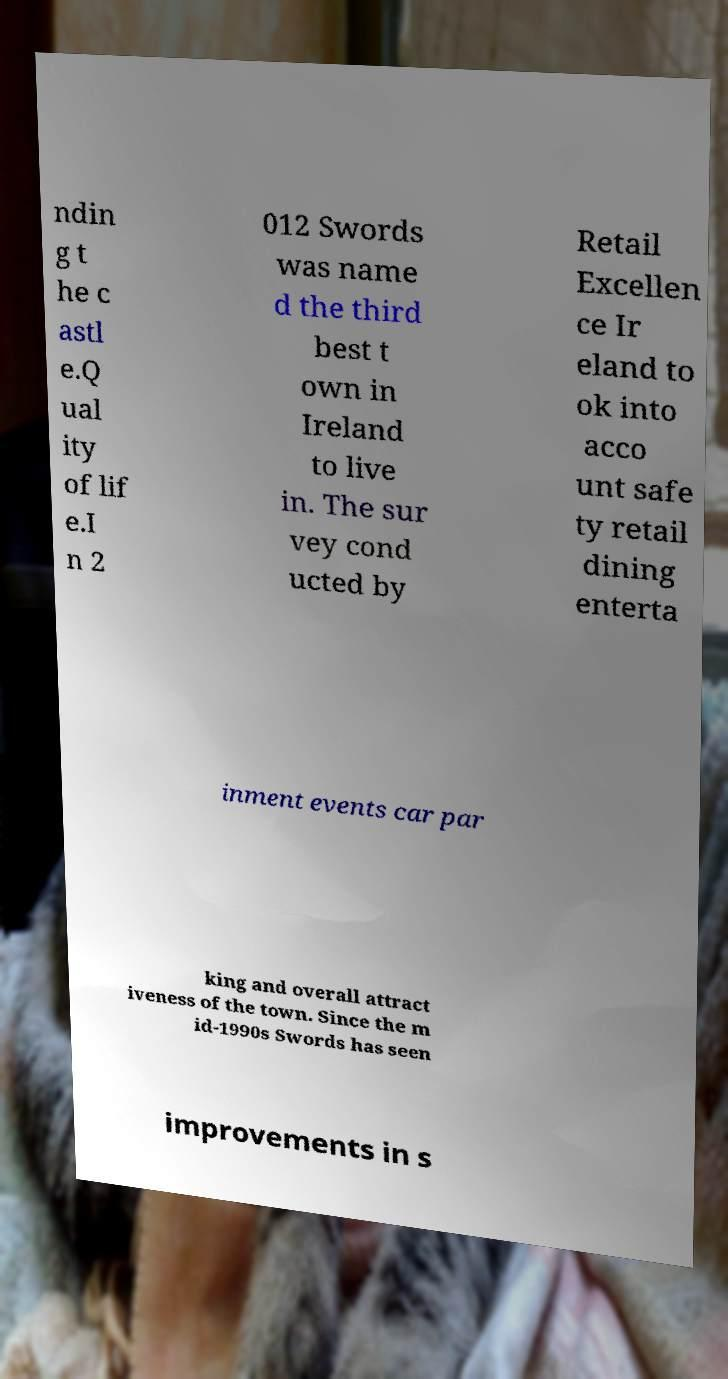Could you extract and type out the text from this image? ndin g t he c astl e.Q ual ity of lif e.I n 2 012 Swords was name d the third best t own in Ireland to live in. The sur vey cond ucted by Retail Excellen ce Ir eland to ok into acco unt safe ty retail dining enterta inment events car par king and overall attract iveness of the town. Since the m id-1990s Swords has seen improvements in s 